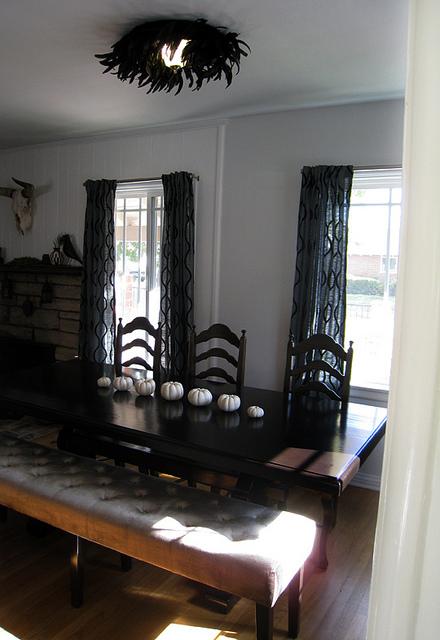Is there a bench at the table?
Short answer required. Yes. What is the shape of the piece of art in the center of the room?
Be succinct. Round. How many chairs are seated at the table?
Short answer required. 3. What kind of skeleton is in the picture?
Quick response, please. Bull. 